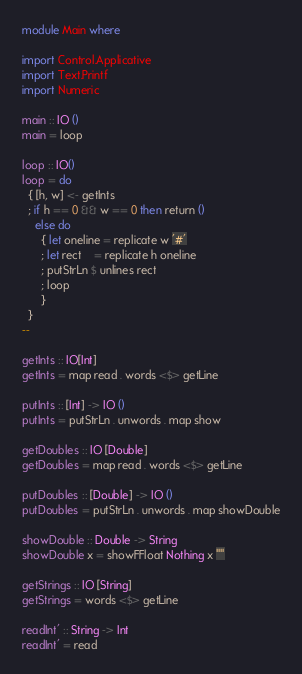<code> <loc_0><loc_0><loc_500><loc_500><_Haskell_>module Main where

import Control.Applicative
import Text.Printf
import Numeric

main :: IO ()
main = loop

loop :: IO()
loop = do
  { [h, w] <- getInts
  ; if h == 0 && w == 0 then return ()
    else do
      { let oneline = replicate w '#'
      ; let rect    = replicate h oneline
      ; putStrLn $ unlines rect
      ; loop
      }
  }
--

getInts :: IO[Int]
getInts = map read . words <$> getLine

putInts :: [Int] -> IO ()
putInts = putStrLn . unwords . map show

getDoubles :: IO [Double]
getDoubles = map read . words <$> getLine

putDoubles :: [Double] -> IO ()
putDoubles = putStrLn . unwords . map showDouble

showDouble :: Double -> String
showDouble x = showFFloat Nothing x ""

getStrings :: IO [String]
getStrings = words <$> getLine

readInt' :: String -> Int
readInt' = read 

</code> 